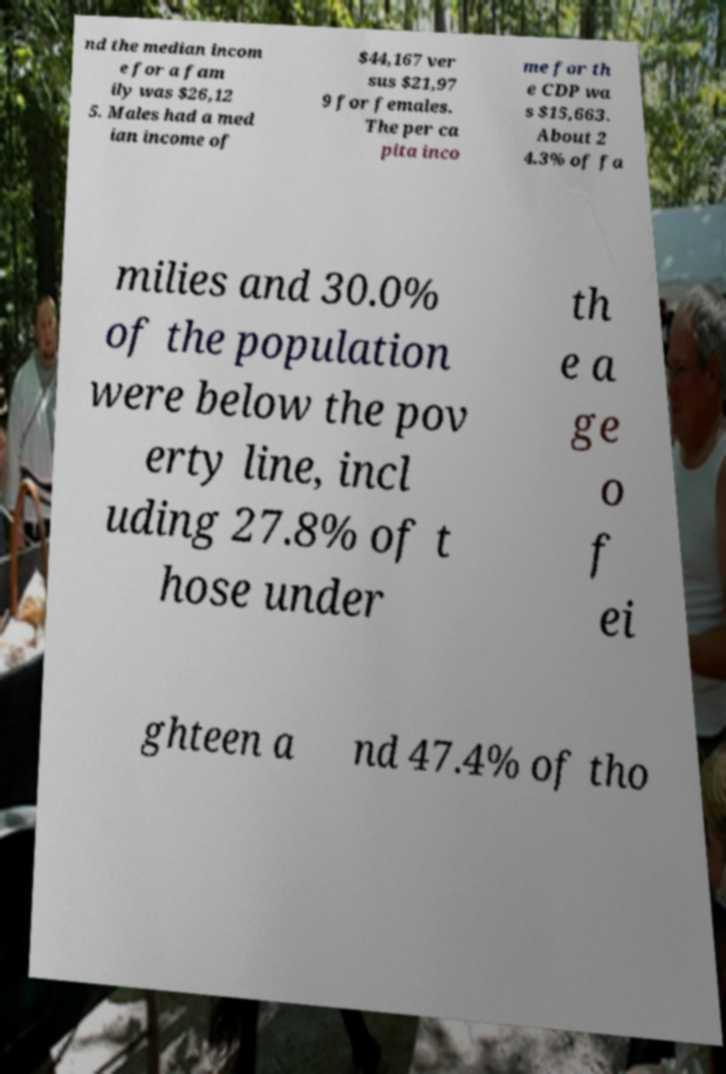Please read and relay the text visible in this image. What does it say? nd the median incom e for a fam ily was $26,12 5. Males had a med ian income of $44,167 ver sus $21,97 9 for females. The per ca pita inco me for th e CDP wa s $15,663. About 2 4.3% of fa milies and 30.0% of the population were below the pov erty line, incl uding 27.8% of t hose under th e a ge o f ei ghteen a nd 47.4% of tho 